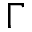<formula> <loc_0><loc_0><loc_500><loc_500>\Gamma</formula> 